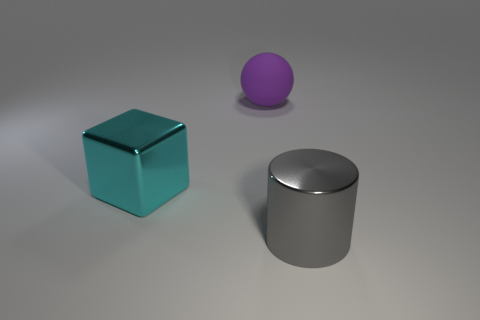Add 3 metal things. How many objects exist? 6 Subtract all cubes. How many objects are left? 2 Subtract 0 green cubes. How many objects are left? 3 Subtract all metallic cylinders. Subtract all cyan objects. How many objects are left? 1 Add 2 large purple rubber balls. How many large purple rubber balls are left? 3 Add 3 large spheres. How many large spheres exist? 4 